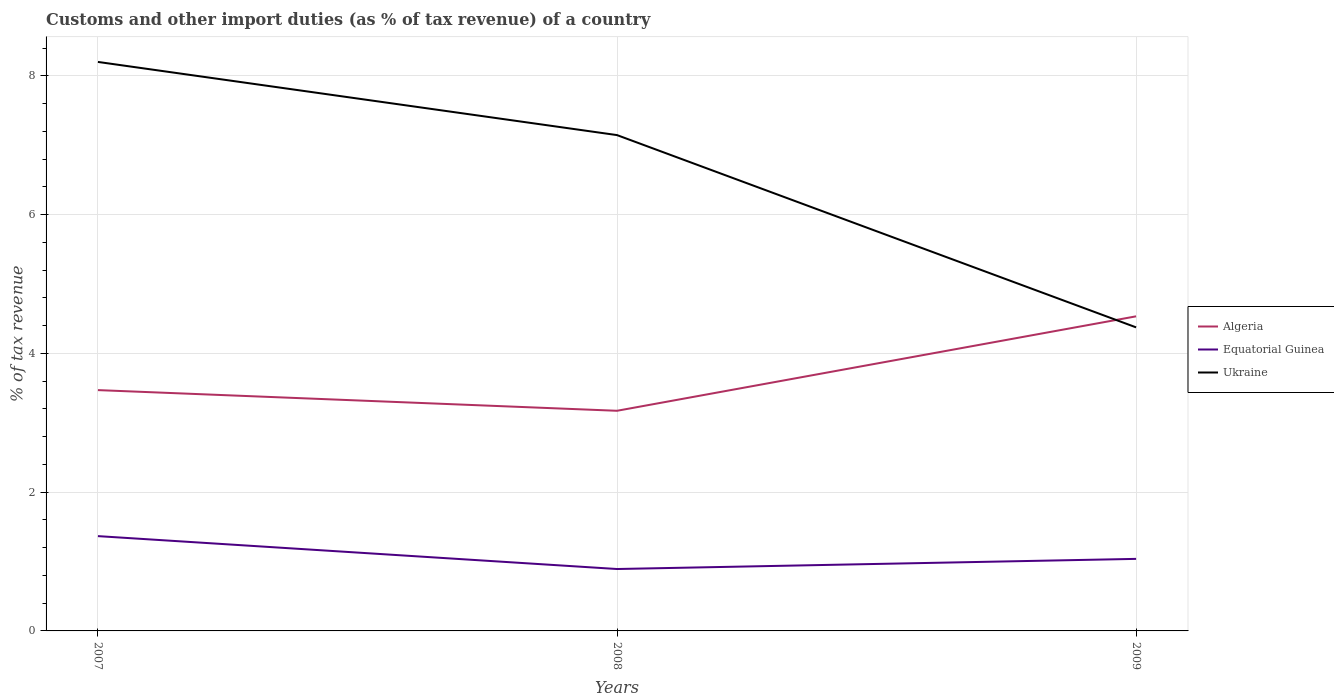How many different coloured lines are there?
Give a very brief answer. 3. Does the line corresponding to Algeria intersect with the line corresponding to Ukraine?
Keep it short and to the point. Yes. Across all years, what is the maximum percentage of tax revenue from customs in Ukraine?
Make the answer very short. 4.38. What is the total percentage of tax revenue from customs in Equatorial Guinea in the graph?
Offer a very short reply. -0.15. What is the difference between the highest and the second highest percentage of tax revenue from customs in Equatorial Guinea?
Offer a very short reply. 0.47. What is the difference between the highest and the lowest percentage of tax revenue from customs in Equatorial Guinea?
Provide a short and direct response. 1. Is the percentage of tax revenue from customs in Algeria strictly greater than the percentage of tax revenue from customs in Equatorial Guinea over the years?
Ensure brevity in your answer.  No. How many lines are there?
Ensure brevity in your answer.  3. What is the difference between two consecutive major ticks on the Y-axis?
Offer a very short reply. 2. Does the graph contain any zero values?
Ensure brevity in your answer.  No. Does the graph contain grids?
Your response must be concise. Yes. Where does the legend appear in the graph?
Offer a terse response. Center right. What is the title of the graph?
Make the answer very short. Customs and other import duties (as % of tax revenue) of a country. Does "Middle income" appear as one of the legend labels in the graph?
Keep it short and to the point. No. What is the label or title of the X-axis?
Your response must be concise. Years. What is the label or title of the Y-axis?
Give a very brief answer. % of tax revenue. What is the % of tax revenue of Algeria in 2007?
Your answer should be compact. 3.47. What is the % of tax revenue of Equatorial Guinea in 2007?
Keep it short and to the point. 1.37. What is the % of tax revenue of Ukraine in 2007?
Provide a succinct answer. 8.2. What is the % of tax revenue of Algeria in 2008?
Your answer should be compact. 3.17. What is the % of tax revenue of Equatorial Guinea in 2008?
Your answer should be very brief. 0.89. What is the % of tax revenue of Ukraine in 2008?
Ensure brevity in your answer.  7.15. What is the % of tax revenue of Algeria in 2009?
Offer a terse response. 4.53. What is the % of tax revenue in Equatorial Guinea in 2009?
Your response must be concise. 1.04. What is the % of tax revenue in Ukraine in 2009?
Your response must be concise. 4.38. Across all years, what is the maximum % of tax revenue in Algeria?
Your answer should be compact. 4.53. Across all years, what is the maximum % of tax revenue of Equatorial Guinea?
Give a very brief answer. 1.37. Across all years, what is the maximum % of tax revenue of Ukraine?
Make the answer very short. 8.2. Across all years, what is the minimum % of tax revenue in Algeria?
Give a very brief answer. 3.17. Across all years, what is the minimum % of tax revenue in Equatorial Guinea?
Keep it short and to the point. 0.89. Across all years, what is the minimum % of tax revenue of Ukraine?
Make the answer very short. 4.38. What is the total % of tax revenue of Algeria in the graph?
Make the answer very short. 11.18. What is the total % of tax revenue of Equatorial Guinea in the graph?
Provide a short and direct response. 3.3. What is the total % of tax revenue of Ukraine in the graph?
Your answer should be compact. 19.72. What is the difference between the % of tax revenue of Algeria in 2007 and that in 2008?
Offer a very short reply. 0.3. What is the difference between the % of tax revenue of Equatorial Guinea in 2007 and that in 2008?
Provide a short and direct response. 0.47. What is the difference between the % of tax revenue in Ukraine in 2007 and that in 2008?
Make the answer very short. 1.05. What is the difference between the % of tax revenue of Algeria in 2007 and that in 2009?
Give a very brief answer. -1.06. What is the difference between the % of tax revenue of Equatorial Guinea in 2007 and that in 2009?
Your answer should be compact. 0.33. What is the difference between the % of tax revenue in Ukraine in 2007 and that in 2009?
Offer a terse response. 3.83. What is the difference between the % of tax revenue of Algeria in 2008 and that in 2009?
Offer a terse response. -1.36. What is the difference between the % of tax revenue of Equatorial Guinea in 2008 and that in 2009?
Ensure brevity in your answer.  -0.15. What is the difference between the % of tax revenue in Ukraine in 2008 and that in 2009?
Your answer should be compact. 2.77. What is the difference between the % of tax revenue of Algeria in 2007 and the % of tax revenue of Equatorial Guinea in 2008?
Offer a very short reply. 2.58. What is the difference between the % of tax revenue of Algeria in 2007 and the % of tax revenue of Ukraine in 2008?
Your response must be concise. -3.68. What is the difference between the % of tax revenue of Equatorial Guinea in 2007 and the % of tax revenue of Ukraine in 2008?
Your answer should be very brief. -5.78. What is the difference between the % of tax revenue in Algeria in 2007 and the % of tax revenue in Equatorial Guinea in 2009?
Provide a short and direct response. 2.43. What is the difference between the % of tax revenue in Algeria in 2007 and the % of tax revenue in Ukraine in 2009?
Keep it short and to the point. -0.9. What is the difference between the % of tax revenue of Equatorial Guinea in 2007 and the % of tax revenue of Ukraine in 2009?
Offer a very short reply. -3.01. What is the difference between the % of tax revenue of Algeria in 2008 and the % of tax revenue of Equatorial Guinea in 2009?
Give a very brief answer. 2.13. What is the difference between the % of tax revenue in Algeria in 2008 and the % of tax revenue in Ukraine in 2009?
Your answer should be compact. -1.2. What is the difference between the % of tax revenue in Equatorial Guinea in 2008 and the % of tax revenue in Ukraine in 2009?
Offer a terse response. -3.48. What is the average % of tax revenue in Algeria per year?
Give a very brief answer. 3.73. What is the average % of tax revenue in Equatorial Guinea per year?
Your answer should be very brief. 1.1. What is the average % of tax revenue in Ukraine per year?
Your answer should be very brief. 6.57. In the year 2007, what is the difference between the % of tax revenue of Algeria and % of tax revenue of Equatorial Guinea?
Offer a very short reply. 2.1. In the year 2007, what is the difference between the % of tax revenue in Algeria and % of tax revenue in Ukraine?
Keep it short and to the point. -4.73. In the year 2007, what is the difference between the % of tax revenue of Equatorial Guinea and % of tax revenue of Ukraine?
Your answer should be compact. -6.83. In the year 2008, what is the difference between the % of tax revenue of Algeria and % of tax revenue of Equatorial Guinea?
Your answer should be very brief. 2.28. In the year 2008, what is the difference between the % of tax revenue of Algeria and % of tax revenue of Ukraine?
Provide a succinct answer. -3.97. In the year 2008, what is the difference between the % of tax revenue of Equatorial Guinea and % of tax revenue of Ukraine?
Ensure brevity in your answer.  -6.25. In the year 2009, what is the difference between the % of tax revenue of Algeria and % of tax revenue of Equatorial Guinea?
Offer a very short reply. 3.5. In the year 2009, what is the difference between the % of tax revenue in Algeria and % of tax revenue in Ukraine?
Give a very brief answer. 0.16. In the year 2009, what is the difference between the % of tax revenue in Equatorial Guinea and % of tax revenue in Ukraine?
Provide a short and direct response. -3.34. What is the ratio of the % of tax revenue in Algeria in 2007 to that in 2008?
Provide a short and direct response. 1.09. What is the ratio of the % of tax revenue of Equatorial Guinea in 2007 to that in 2008?
Provide a succinct answer. 1.53. What is the ratio of the % of tax revenue in Ukraine in 2007 to that in 2008?
Your response must be concise. 1.15. What is the ratio of the % of tax revenue in Algeria in 2007 to that in 2009?
Offer a terse response. 0.77. What is the ratio of the % of tax revenue in Equatorial Guinea in 2007 to that in 2009?
Provide a succinct answer. 1.32. What is the ratio of the % of tax revenue of Ukraine in 2007 to that in 2009?
Your response must be concise. 1.87. What is the ratio of the % of tax revenue in Algeria in 2008 to that in 2009?
Your response must be concise. 0.7. What is the ratio of the % of tax revenue of Equatorial Guinea in 2008 to that in 2009?
Your response must be concise. 0.86. What is the ratio of the % of tax revenue in Ukraine in 2008 to that in 2009?
Your answer should be very brief. 1.63. What is the difference between the highest and the second highest % of tax revenue of Algeria?
Your answer should be very brief. 1.06. What is the difference between the highest and the second highest % of tax revenue in Equatorial Guinea?
Keep it short and to the point. 0.33. What is the difference between the highest and the second highest % of tax revenue in Ukraine?
Offer a very short reply. 1.05. What is the difference between the highest and the lowest % of tax revenue in Algeria?
Provide a succinct answer. 1.36. What is the difference between the highest and the lowest % of tax revenue of Equatorial Guinea?
Offer a terse response. 0.47. What is the difference between the highest and the lowest % of tax revenue in Ukraine?
Your answer should be very brief. 3.83. 